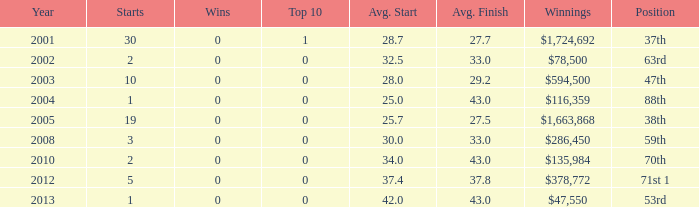What is the average top 10 score for 2 starts, winnings of $135,984 and an average finish more than 43? None. 